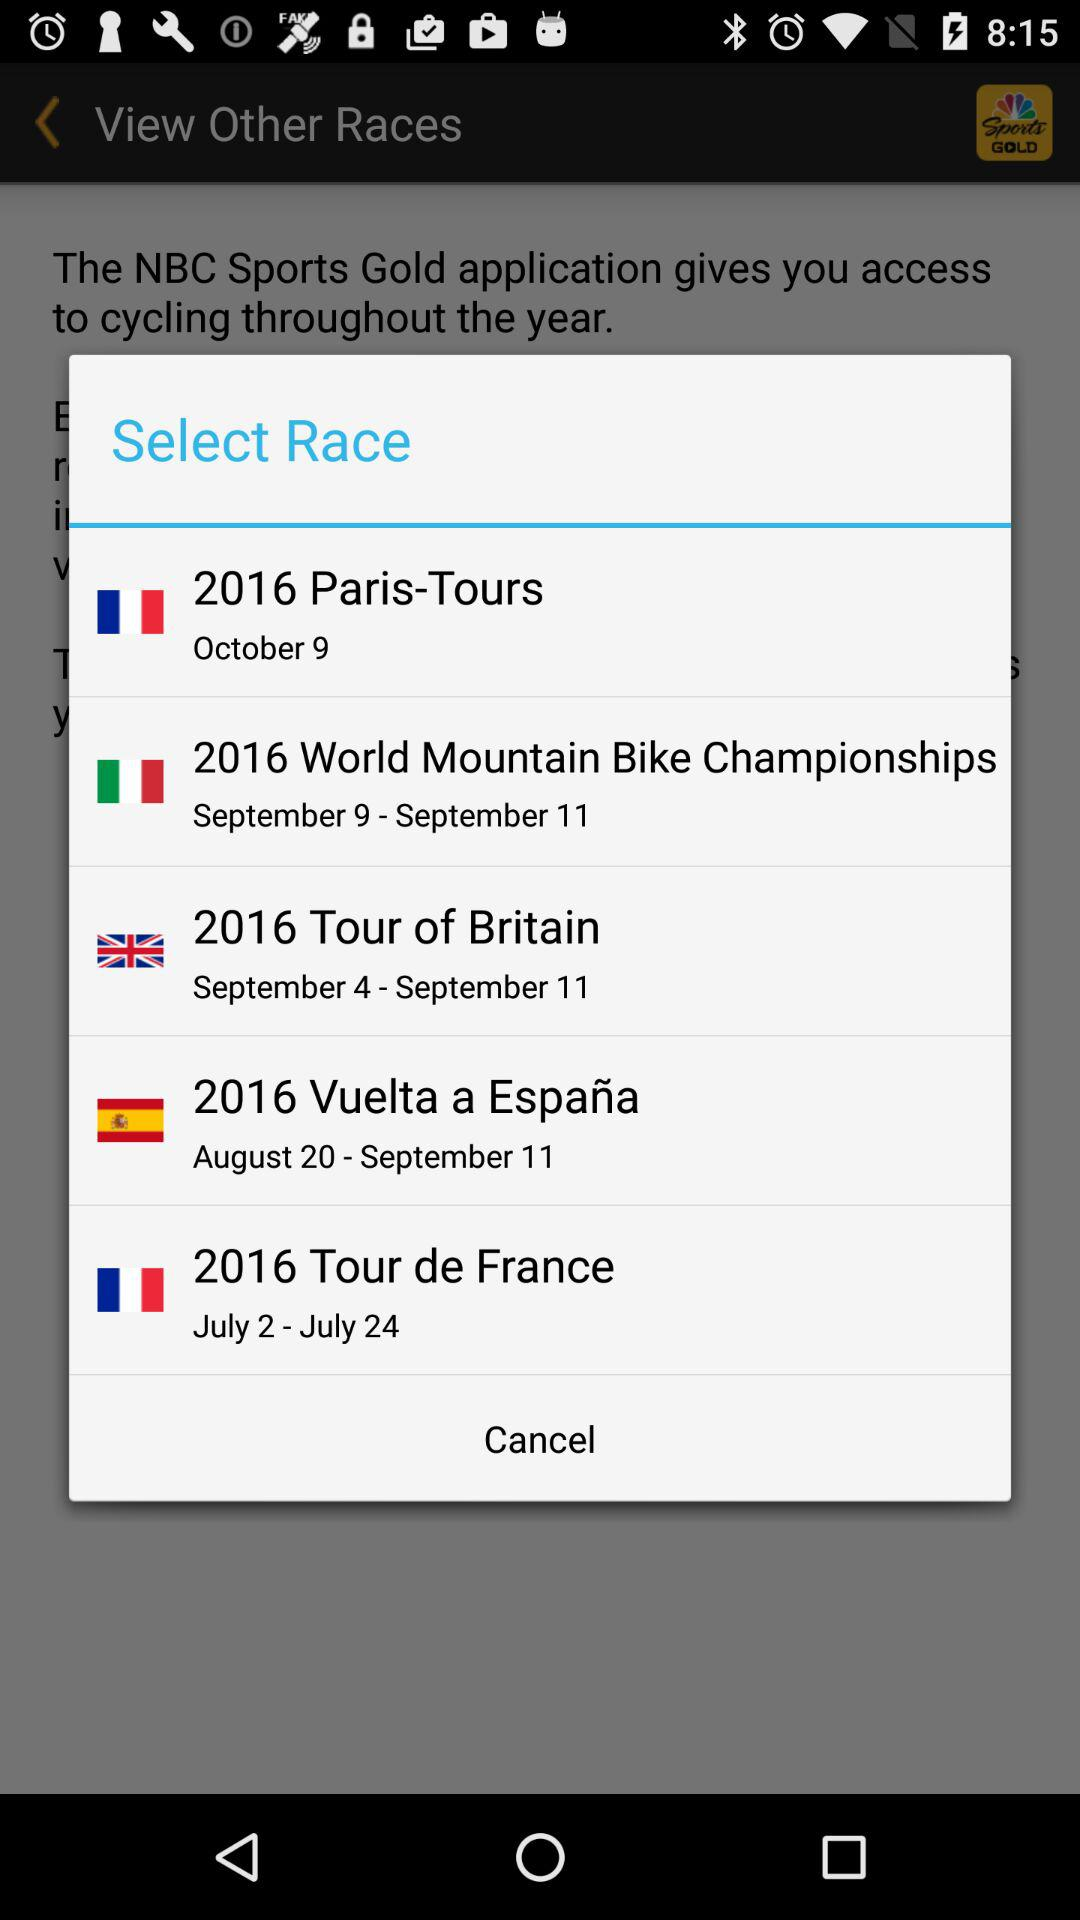What is the date of the 2016 Tour of Britain? The dates of the 2016 Tour of Britain are September 4–September 11. 